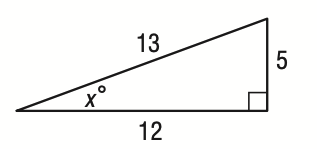Answer the mathemtical geometry problem and directly provide the correct option letter.
Question: What is the value of \tan x?
Choices: A: \frac { 5 } { 13 } B: \frac { 5 } { 12 } C: \frac { 12 } { 5 } D: \frac { 13 } { 5 } B 